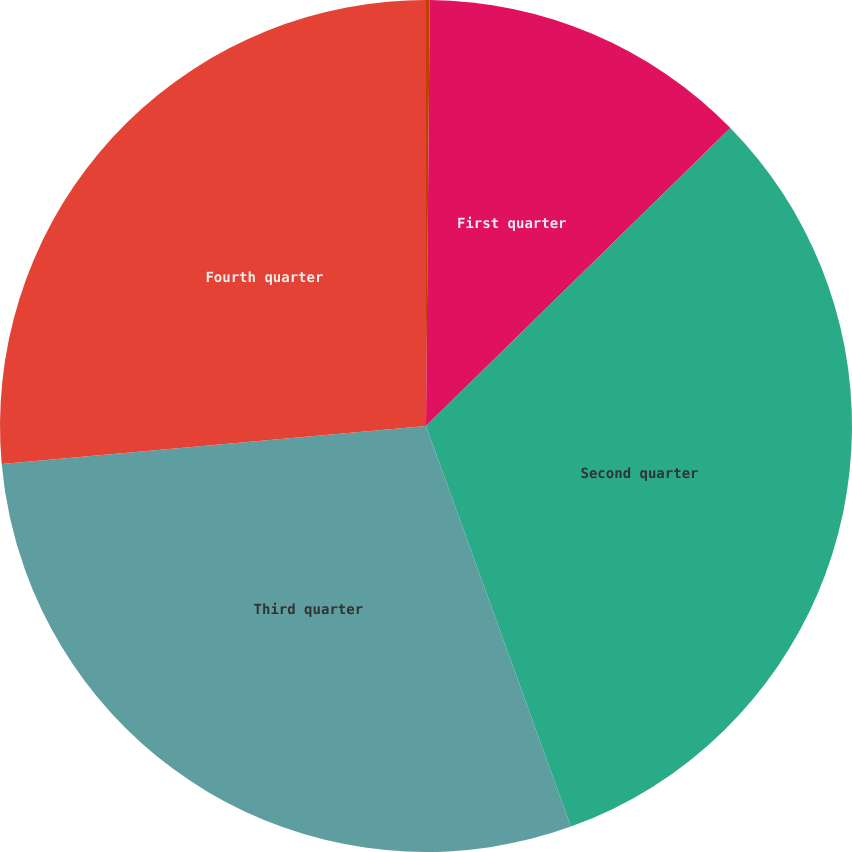<chart> <loc_0><loc_0><loc_500><loc_500><pie_chart><fcel>Peak borrowings<fcel>First quarter<fcel>Second quarter<fcel>Third quarter<fcel>Fourth quarter<nl><fcel>0.14%<fcel>12.53%<fcel>31.81%<fcel>29.11%<fcel>26.42%<nl></chart> 